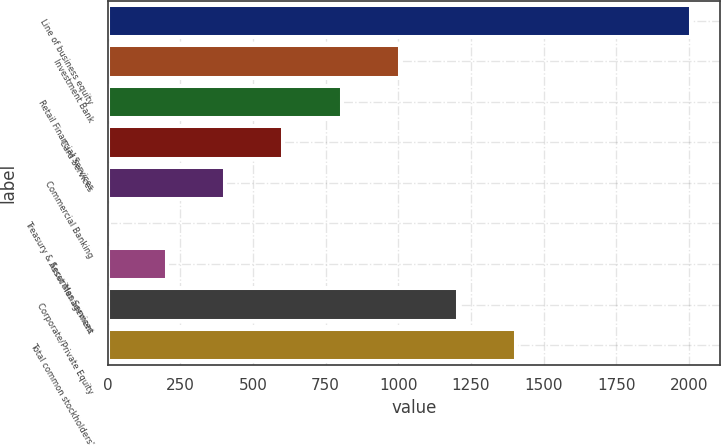Convert chart. <chart><loc_0><loc_0><loc_500><loc_500><bar_chart><fcel>Line of business equity<fcel>Investment Bank<fcel>Retail Financial Services<fcel>Card Services<fcel>Commercial Banking<fcel>Treasury & Securities Services<fcel>Asset Management<fcel>Corporate/Private Equity<fcel>Total common stockholders'<nl><fcel>2007<fcel>1005<fcel>804.6<fcel>604.2<fcel>403.8<fcel>3<fcel>203.4<fcel>1205.4<fcel>1405.8<nl></chart> 